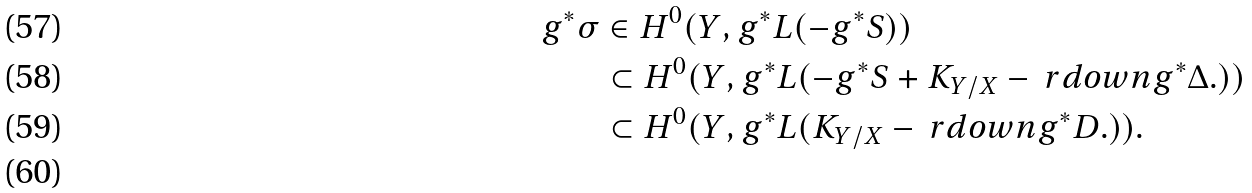<formula> <loc_0><loc_0><loc_500><loc_500>g ^ { * } \sigma & \in H ^ { 0 } ( Y , g ^ { * } L ( - g ^ { * } S ) ) \\ & \subset H ^ { 0 } ( Y , g ^ { * } L ( - g ^ { * } S + K _ { Y / X } - \ r d o w n g ^ { * } \Delta . ) ) \\ & \subset H ^ { 0 } ( Y , g ^ { * } L ( K _ { Y / X } - \ r d o w n g ^ { * } D . ) ) . \\</formula> 